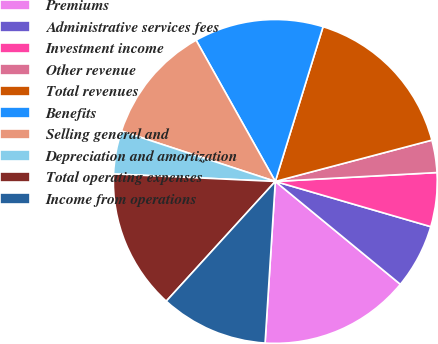Convert chart to OTSL. <chart><loc_0><loc_0><loc_500><loc_500><pie_chart><fcel>Premiums<fcel>Administrative services fees<fcel>Investment income<fcel>Other revenue<fcel>Total revenues<fcel>Benefits<fcel>Selling general and<fcel>Depreciation and amortization<fcel>Total operating expenses<fcel>Income from operations<nl><fcel>15.05%<fcel>6.45%<fcel>5.38%<fcel>3.23%<fcel>16.13%<fcel>12.9%<fcel>11.83%<fcel>4.3%<fcel>13.98%<fcel>10.75%<nl></chart> 